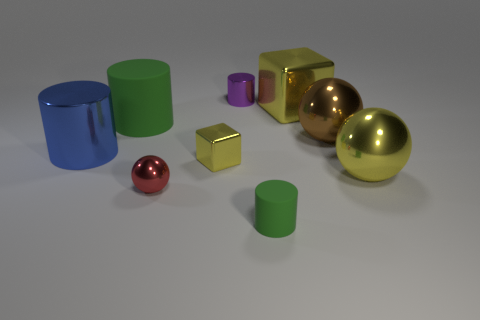Subtract all red spheres. How many green cylinders are left? 2 Subtract all tiny purple cylinders. How many cylinders are left? 3 Subtract all purple cylinders. How many cylinders are left? 3 Add 1 small yellow metallic objects. How many objects exist? 10 Subtract all cyan cylinders. Subtract all green blocks. How many cylinders are left? 4 Subtract all spheres. How many objects are left? 6 Add 1 metal objects. How many metal objects exist? 8 Subtract 0 green cubes. How many objects are left? 9 Subtract all big matte cylinders. Subtract all big green rubber objects. How many objects are left? 7 Add 4 big yellow metal blocks. How many big yellow metal blocks are left? 5 